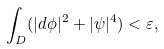<formula> <loc_0><loc_0><loc_500><loc_500>\int _ { D } ( | d \phi | ^ { 2 } + | \psi | ^ { 4 } ) < \varepsilon ,</formula> 